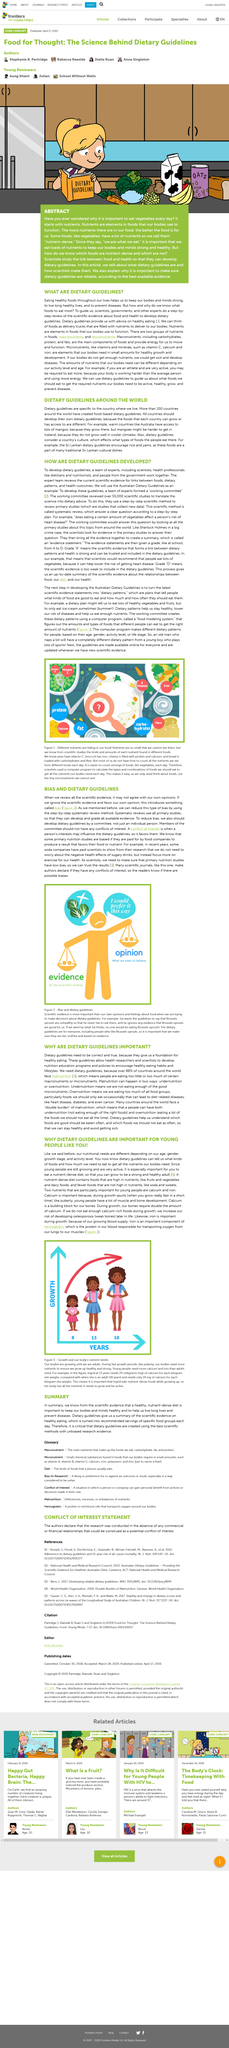Highlight a few significant elements in this photo. Nutrients are essential elements in food that our bodies require to function properly, and they play a critical role in maintaining overall health and well-being. In Australia, mangos are readily available and can be found in most supermarkets, whereas in Iceland, they are harder to come by and may only be available in specialty stores or markets. According to scientific evidence, adherence to healthy eating patterns, as outlined in dietary guidelines, has been shown to improve overall health and prevent chronic diseases. Over 100 countries have implemented food-based dietary guidelines, reflecting a global commitment to promoting healthy eating habits. The Sri Lankan dietary guidelines recommend the consumption of rice and yams as part of a balanced and healthy diet. 